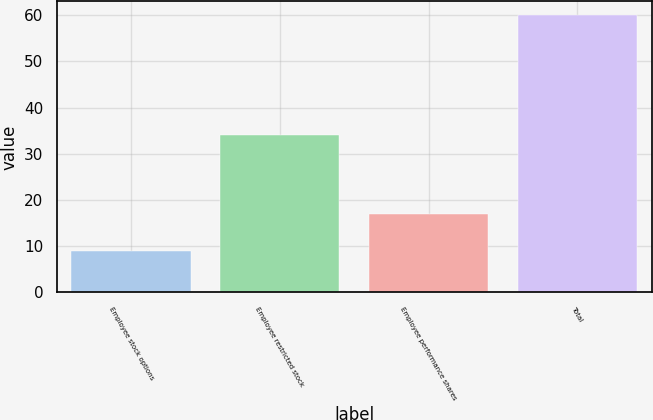Convert chart. <chart><loc_0><loc_0><loc_500><loc_500><bar_chart><fcel>Employee stock options<fcel>Employee restricted stock<fcel>Employee performance shares<fcel>Total<nl><fcel>9<fcel>34<fcel>17<fcel>60<nl></chart> 